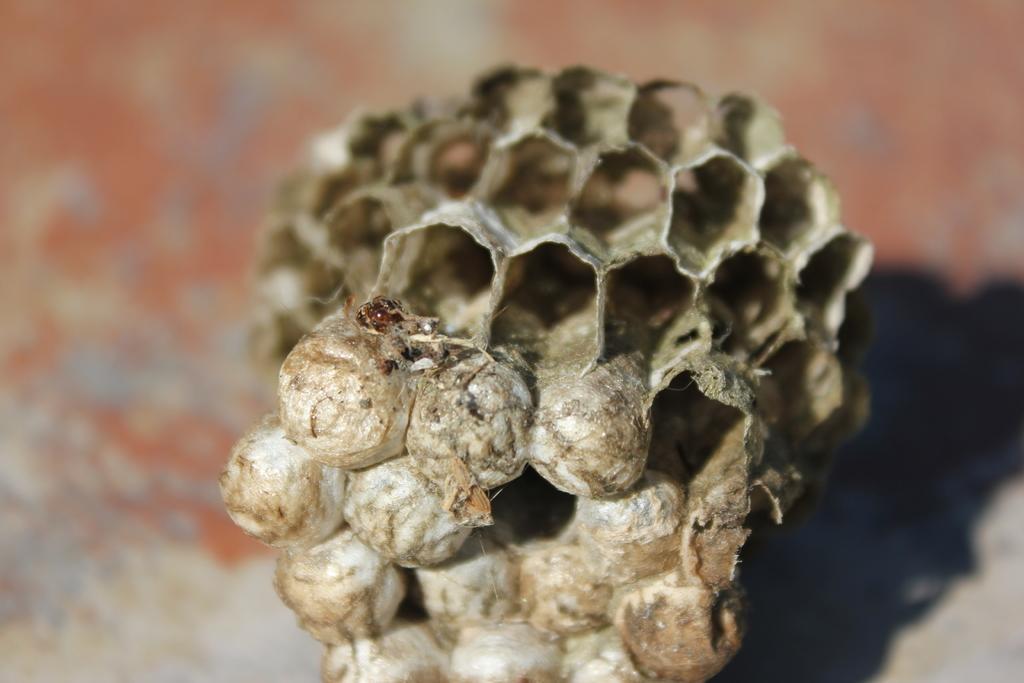Please provide a concise description of this image. In this picture it is looking like a dry honeycomb which is in grey color. The background is completely blurred. 